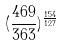Convert formula to latex. <formula><loc_0><loc_0><loc_500><loc_500>( \frac { 4 6 9 } { 3 6 3 } ) ^ { \frac { 1 5 4 } { 1 2 7 } }</formula> 